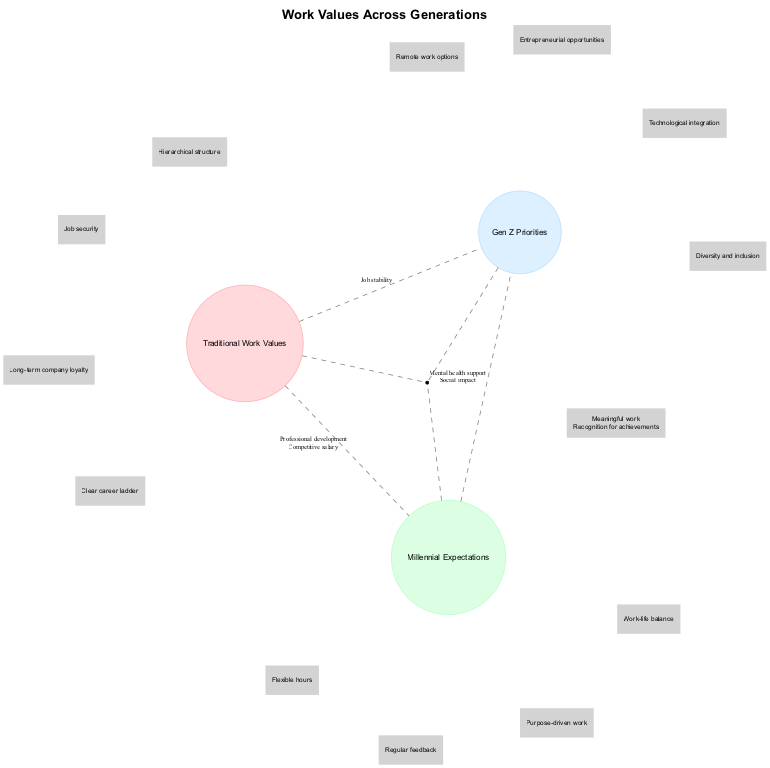What are the elements listed under Traditional Work Values? The diagram shows that the elements under Traditional Work Values are job security, hierarchical structure, long-term company loyalty, and clear career ladder. Each of these elements is represented as a part of the circle labeled "Traditional Work Values."
Answer: Job security, hierarchical structure, long-term company loyalty, clear career ladder How many elements are common between Millennial Expectations and Gen Z Priorities? The overlap between Millennial Expectations and Gen Z Priorities includes two elements: mental health support and social impact. Therefore, the number of common elements is determined by counting these elements.
Answer: 2 What is a shared value between Traditional Work Values and Millennial Expectations? By examining the overlap between Traditional Work Values and Millennial Expectations, we find that professional development and competitive salary are shared values. Thus, any one of these can be the answer.
Answer: Professional development Which generation prioritizes remote work options? The elements listed under Gen Z Priorities include remote work options, indicating that this generation is focused on such flexibility in the workplace, according to the information provided in the diagram.
Answer: Gen Z What is the common element discussed among all three generations? The shared elements among Traditional Work Values, Millennial Expectations, and Gen Z Priorities are meaningful work and recognition for achievements. This means both elements are central to each generation's perspective on work.
Answer: Meaningful work, recognition for achievements What do all three generations seek in the workplace according to the diagram? Each of the circles in the diagram indicates that all three generations, Traditional, Millennial, and Gen Z, seek both meaningful work and recognition for achievements. This is encapsulated in their overlapping region.
Answer: Meaningful work, recognition for achievements How many total distinct elements are shown in Traditional Work Values? The diagram lists four distinct elements under Traditional Work Values: job security, hierarchical structure, long-term company loyalty, and clear career ladder. The total number of these elements is counted directly from the representation in the diagram.
Answer: 4 What value connects Traditional Work Values and Gen Z Priorities? The common element between Traditional Work Values and Gen Z Priorities is job stability, as indicated in the part of the diagram that highlights their overlap. This reflects a shared concern of both generations.
Answer: Job stability 